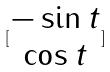<formula> <loc_0><loc_0><loc_500><loc_500>[ \begin{matrix} - \sin t \\ \cos t \end{matrix} ]</formula> 